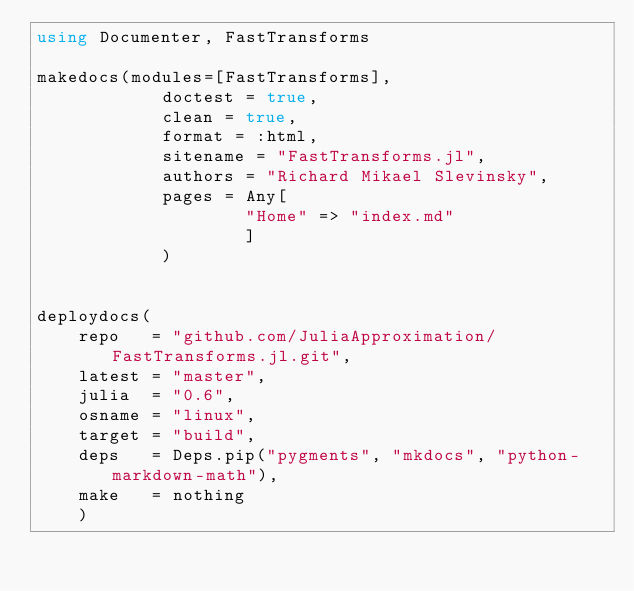<code> <loc_0><loc_0><loc_500><loc_500><_Julia_>using Documenter, FastTransforms

makedocs(modules=[FastTransforms],
			doctest = true,
			clean = true,
			format = :html,
			sitename = "FastTransforms.jl",
			authors = "Richard Mikael Slevinsky",
			pages = Any[
					"Home" => "index.md"
					]
			)


deploydocs(
    repo   = "github.com/JuliaApproximation/FastTransforms.jl.git",
    latest = "master",
    julia  = "0.6",
    osname = "linux",
    target = "build",
    deps   = Deps.pip("pygments", "mkdocs", "python-markdown-math"),
    make   = nothing
    )
</code> 